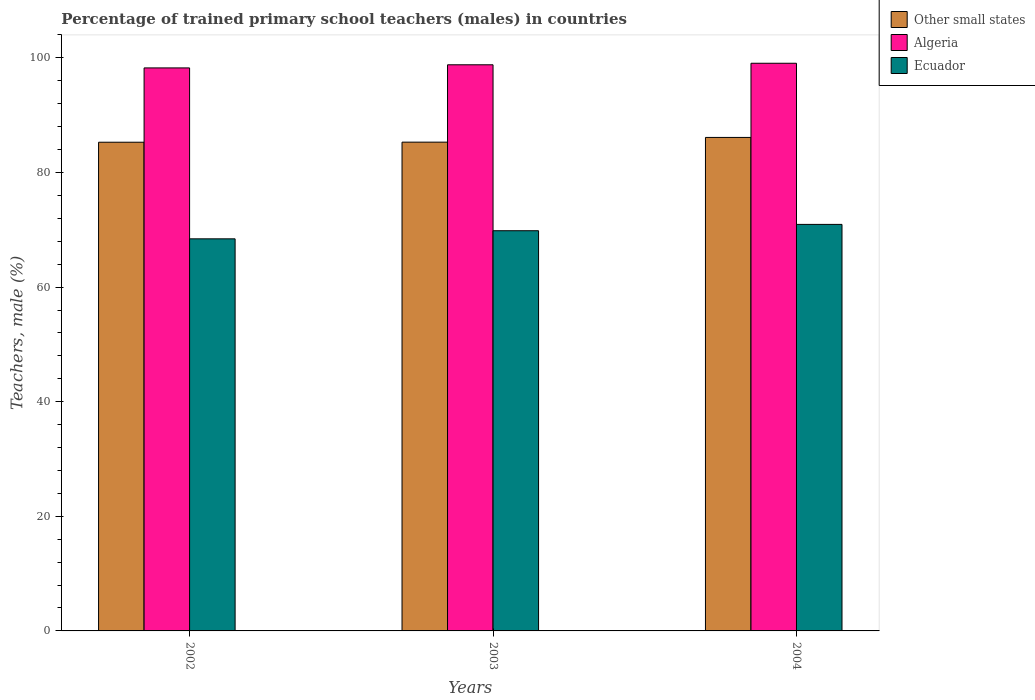How many different coloured bars are there?
Make the answer very short. 3. How many groups of bars are there?
Ensure brevity in your answer.  3. Are the number of bars on each tick of the X-axis equal?
Keep it short and to the point. Yes. How many bars are there on the 1st tick from the right?
Provide a succinct answer. 3. What is the percentage of trained primary school teachers (males) in Ecuador in 2003?
Give a very brief answer. 69.83. Across all years, what is the maximum percentage of trained primary school teachers (males) in Algeria?
Give a very brief answer. 99.06. Across all years, what is the minimum percentage of trained primary school teachers (males) in Other small states?
Your answer should be compact. 85.28. In which year was the percentage of trained primary school teachers (males) in Algeria maximum?
Offer a terse response. 2004. In which year was the percentage of trained primary school teachers (males) in Other small states minimum?
Your response must be concise. 2002. What is the total percentage of trained primary school teachers (males) in Ecuador in the graph?
Your answer should be compact. 209.19. What is the difference between the percentage of trained primary school teachers (males) in Other small states in 2003 and that in 2004?
Your answer should be very brief. -0.82. What is the difference between the percentage of trained primary school teachers (males) in Ecuador in 2003 and the percentage of trained primary school teachers (males) in Other small states in 2002?
Your response must be concise. -15.45. What is the average percentage of trained primary school teachers (males) in Algeria per year?
Offer a very short reply. 98.7. In the year 2003, what is the difference between the percentage of trained primary school teachers (males) in Ecuador and percentage of trained primary school teachers (males) in Other small states?
Provide a succinct answer. -15.46. What is the ratio of the percentage of trained primary school teachers (males) in Other small states in 2002 to that in 2003?
Keep it short and to the point. 1. Is the difference between the percentage of trained primary school teachers (males) in Ecuador in 2002 and 2004 greater than the difference between the percentage of trained primary school teachers (males) in Other small states in 2002 and 2004?
Make the answer very short. No. What is the difference between the highest and the second highest percentage of trained primary school teachers (males) in Algeria?
Keep it short and to the point. 0.27. What is the difference between the highest and the lowest percentage of trained primary school teachers (males) in Other small states?
Offer a terse response. 0.84. What does the 1st bar from the left in 2003 represents?
Make the answer very short. Other small states. What does the 1st bar from the right in 2003 represents?
Ensure brevity in your answer.  Ecuador. Is it the case that in every year, the sum of the percentage of trained primary school teachers (males) in Algeria and percentage of trained primary school teachers (males) in Ecuador is greater than the percentage of trained primary school teachers (males) in Other small states?
Give a very brief answer. Yes. How many years are there in the graph?
Provide a short and direct response. 3. What is the difference between two consecutive major ticks on the Y-axis?
Make the answer very short. 20. Are the values on the major ticks of Y-axis written in scientific E-notation?
Your answer should be very brief. No. Does the graph contain any zero values?
Your answer should be compact. No. Where does the legend appear in the graph?
Your answer should be very brief. Top right. How many legend labels are there?
Make the answer very short. 3. How are the legend labels stacked?
Give a very brief answer. Vertical. What is the title of the graph?
Offer a very short reply. Percentage of trained primary school teachers (males) in countries. Does "World" appear as one of the legend labels in the graph?
Your answer should be compact. No. What is the label or title of the X-axis?
Provide a short and direct response. Years. What is the label or title of the Y-axis?
Make the answer very short. Teachers, male (%). What is the Teachers, male (%) in Other small states in 2002?
Offer a terse response. 85.28. What is the Teachers, male (%) in Algeria in 2002?
Your response must be concise. 98.25. What is the Teachers, male (%) in Ecuador in 2002?
Offer a terse response. 68.42. What is the Teachers, male (%) in Other small states in 2003?
Offer a terse response. 85.29. What is the Teachers, male (%) in Algeria in 2003?
Ensure brevity in your answer.  98.79. What is the Teachers, male (%) of Ecuador in 2003?
Your answer should be compact. 69.83. What is the Teachers, male (%) of Other small states in 2004?
Your answer should be compact. 86.11. What is the Teachers, male (%) in Algeria in 2004?
Make the answer very short. 99.06. What is the Teachers, male (%) in Ecuador in 2004?
Offer a terse response. 70.94. Across all years, what is the maximum Teachers, male (%) in Other small states?
Offer a terse response. 86.11. Across all years, what is the maximum Teachers, male (%) in Algeria?
Give a very brief answer. 99.06. Across all years, what is the maximum Teachers, male (%) of Ecuador?
Keep it short and to the point. 70.94. Across all years, what is the minimum Teachers, male (%) of Other small states?
Offer a terse response. 85.28. Across all years, what is the minimum Teachers, male (%) of Algeria?
Ensure brevity in your answer.  98.25. Across all years, what is the minimum Teachers, male (%) of Ecuador?
Ensure brevity in your answer.  68.42. What is the total Teachers, male (%) in Other small states in the graph?
Your answer should be compact. 256.68. What is the total Teachers, male (%) of Algeria in the graph?
Make the answer very short. 296.09. What is the total Teachers, male (%) in Ecuador in the graph?
Provide a succinct answer. 209.19. What is the difference between the Teachers, male (%) in Other small states in 2002 and that in 2003?
Provide a succinct answer. -0.01. What is the difference between the Teachers, male (%) in Algeria in 2002 and that in 2003?
Offer a terse response. -0.54. What is the difference between the Teachers, male (%) in Ecuador in 2002 and that in 2003?
Provide a short and direct response. -1.41. What is the difference between the Teachers, male (%) in Other small states in 2002 and that in 2004?
Your answer should be compact. -0.84. What is the difference between the Teachers, male (%) in Algeria in 2002 and that in 2004?
Provide a succinct answer. -0.81. What is the difference between the Teachers, male (%) of Ecuador in 2002 and that in 2004?
Provide a succinct answer. -2.52. What is the difference between the Teachers, male (%) in Other small states in 2003 and that in 2004?
Provide a short and direct response. -0.82. What is the difference between the Teachers, male (%) of Algeria in 2003 and that in 2004?
Keep it short and to the point. -0.27. What is the difference between the Teachers, male (%) in Ecuador in 2003 and that in 2004?
Ensure brevity in your answer.  -1.1. What is the difference between the Teachers, male (%) of Other small states in 2002 and the Teachers, male (%) of Algeria in 2003?
Give a very brief answer. -13.51. What is the difference between the Teachers, male (%) in Other small states in 2002 and the Teachers, male (%) in Ecuador in 2003?
Provide a short and direct response. 15.45. What is the difference between the Teachers, male (%) in Algeria in 2002 and the Teachers, male (%) in Ecuador in 2003?
Ensure brevity in your answer.  28.41. What is the difference between the Teachers, male (%) of Other small states in 2002 and the Teachers, male (%) of Algeria in 2004?
Provide a short and direct response. -13.78. What is the difference between the Teachers, male (%) in Other small states in 2002 and the Teachers, male (%) in Ecuador in 2004?
Provide a short and direct response. 14.34. What is the difference between the Teachers, male (%) of Algeria in 2002 and the Teachers, male (%) of Ecuador in 2004?
Give a very brief answer. 27.31. What is the difference between the Teachers, male (%) of Other small states in 2003 and the Teachers, male (%) of Algeria in 2004?
Your response must be concise. -13.77. What is the difference between the Teachers, male (%) of Other small states in 2003 and the Teachers, male (%) of Ecuador in 2004?
Provide a short and direct response. 14.35. What is the difference between the Teachers, male (%) in Algeria in 2003 and the Teachers, male (%) in Ecuador in 2004?
Offer a terse response. 27.85. What is the average Teachers, male (%) in Other small states per year?
Keep it short and to the point. 85.56. What is the average Teachers, male (%) of Algeria per year?
Keep it short and to the point. 98.7. What is the average Teachers, male (%) in Ecuador per year?
Ensure brevity in your answer.  69.73. In the year 2002, what is the difference between the Teachers, male (%) of Other small states and Teachers, male (%) of Algeria?
Your response must be concise. -12.97. In the year 2002, what is the difference between the Teachers, male (%) in Other small states and Teachers, male (%) in Ecuador?
Offer a terse response. 16.86. In the year 2002, what is the difference between the Teachers, male (%) of Algeria and Teachers, male (%) of Ecuador?
Your answer should be compact. 29.83. In the year 2003, what is the difference between the Teachers, male (%) of Other small states and Teachers, male (%) of Algeria?
Keep it short and to the point. -13.5. In the year 2003, what is the difference between the Teachers, male (%) in Other small states and Teachers, male (%) in Ecuador?
Offer a very short reply. 15.46. In the year 2003, what is the difference between the Teachers, male (%) of Algeria and Teachers, male (%) of Ecuador?
Provide a short and direct response. 28.96. In the year 2004, what is the difference between the Teachers, male (%) in Other small states and Teachers, male (%) in Algeria?
Offer a terse response. -12.94. In the year 2004, what is the difference between the Teachers, male (%) of Other small states and Teachers, male (%) of Ecuador?
Your response must be concise. 15.18. In the year 2004, what is the difference between the Teachers, male (%) of Algeria and Teachers, male (%) of Ecuador?
Provide a short and direct response. 28.12. What is the ratio of the Teachers, male (%) of Other small states in 2002 to that in 2003?
Keep it short and to the point. 1. What is the ratio of the Teachers, male (%) in Ecuador in 2002 to that in 2003?
Your response must be concise. 0.98. What is the ratio of the Teachers, male (%) of Other small states in 2002 to that in 2004?
Your answer should be compact. 0.99. What is the ratio of the Teachers, male (%) of Ecuador in 2002 to that in 2004?
Your response must be concise. 0.96. What is the ratio of the Teachers, male (%) in Other small states in 2003 to that in 2004?
Keep it short and to the point. 0.99. What is the ratio of the Teachers, male (%) in Ecuador in 2003 to that in 2004?
Your answer should be compact. 0.98. What is the difference between the highest and the second highest Teachers, male (%) in Other small states?
Offer a terse response. 0.82. What is the difference between the highest and the second highest Teachers, male (%) in Algeria?
Provide a short and direct response. 0.27. What is the difference between the highest and the second highest Teachers, male (%) in Ecuador?
Your answer should be compact. 1.1. What is the difference between the highest and the lowest Teachers, male (%) of Other small states?
Your answer should be compact. 0.84. What is the difference between the highest and the lowest Teachers, male (%) in Algeria?
Your response must be concise. 0.81. What is the difference between the highest and the lowest Teachers, male (%) of Ecuador?
Offer a very short reply. 2.52. 